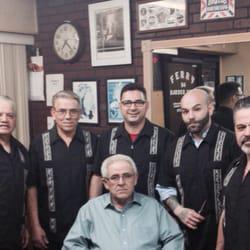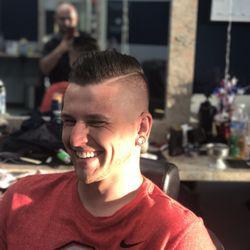The first image is the image on the left, the second image is the image on the right. Evaluate the accuracy of this statement regarding the images: "A barber in a baseball cap is cutting a mans hair, the person getting their hair cut is wearing a protective cover to shield from the falling hair". Is it true? Answer yes or no. No. 